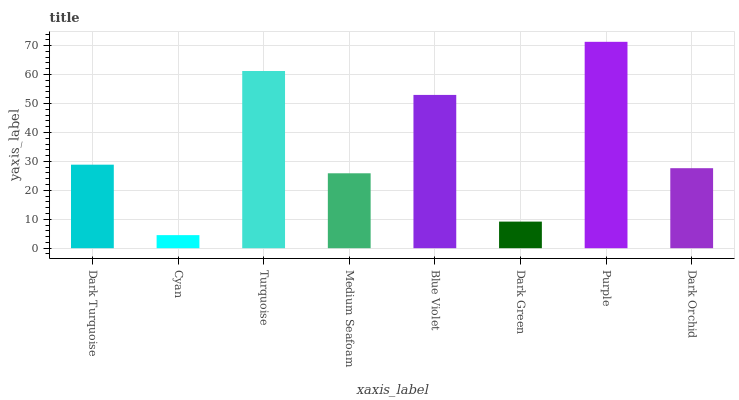Is Cyan the minimum?
Answer yes or no. Yes. Is Purple the maximum?
Answer yes or no. Yes. Is Turquoise the minimum?
Answer yes or no. No. Is Turquoise the maximum?
Answer yes or no. No. Is Turquoise greater than Cyan?
Answer yes or no. Yes. Is Cyan less than Turquoise?
Answer yes or no. Yes. Is Cyan greater than Turquoise?
Answer yes or no. No. Is Turquoise less than Cyan?
Answer yes or no. No. Is Dark Turquoise the high median?
Answer yes or no. Yes. Is Dark Orchid the low median?
Answer yes or no. Yes. Is Dark Orchid the high median?
Answer yes or no. No. Is Dark Green the low median?
Answer yes or no. No. 